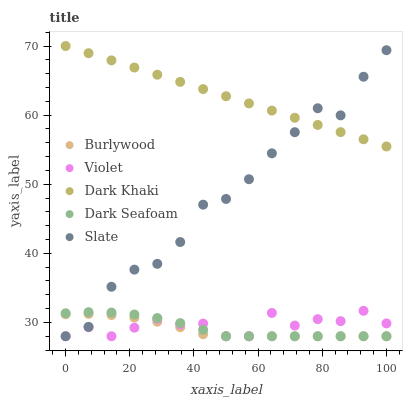Does Burlywood have the minimum area under the curve?
Answer yes or no. Yes. Does Dark Khaki have the maximum area under the curve?
Answer yes or no. Yes. Does Dark Seafoam have the minimum area under the curve?
Answer yes or no. No. Does Dark Seafoam have the maximum area under the curve?
Answer yes or no. No. Is Dark Khaki the smoothest?
Answer yes or no. Yes. Is Slate the roughest?
Answer yes or no. Yes. Is Dark Seafoam the smoothest?
Answer yes or no. No. Is Dark Seafoam the roughest?
Answer yes or no. No. Does Burlywood have the lowest value?
Answer yes or no. Yes. Does Dark Khaki have the lowest value?
Answer yes or no. No. Does Dark Khaki have the highest value?
Answer yes or no. Yes. Does Dark Seafoam have the highest value?
Answer yes or no. No. Is Burlywood less than Dark Khaki?
Answer yes or no. Yes. Is Dark Khaki greater than Burlywood?
Answer yes or no. Yes. Does Violet intersect Slate?
Answer yes or no. Yes. Is Violet less than Slate?
Answer yes or no. No. Is Violet greater than Slate?
Answer yes or no. No. Does Burlywood intersect Dark Khaki?
Answer yes or no. No. 